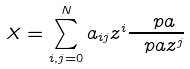<formula> <loc_0><loc_0><loc_500><loc_500>X = \sum _ { i , j = 0 } ^ { N } a _ { i j } z ^ { i } \frac { \ p a } { \ p a z ^ { j } }</formula> 